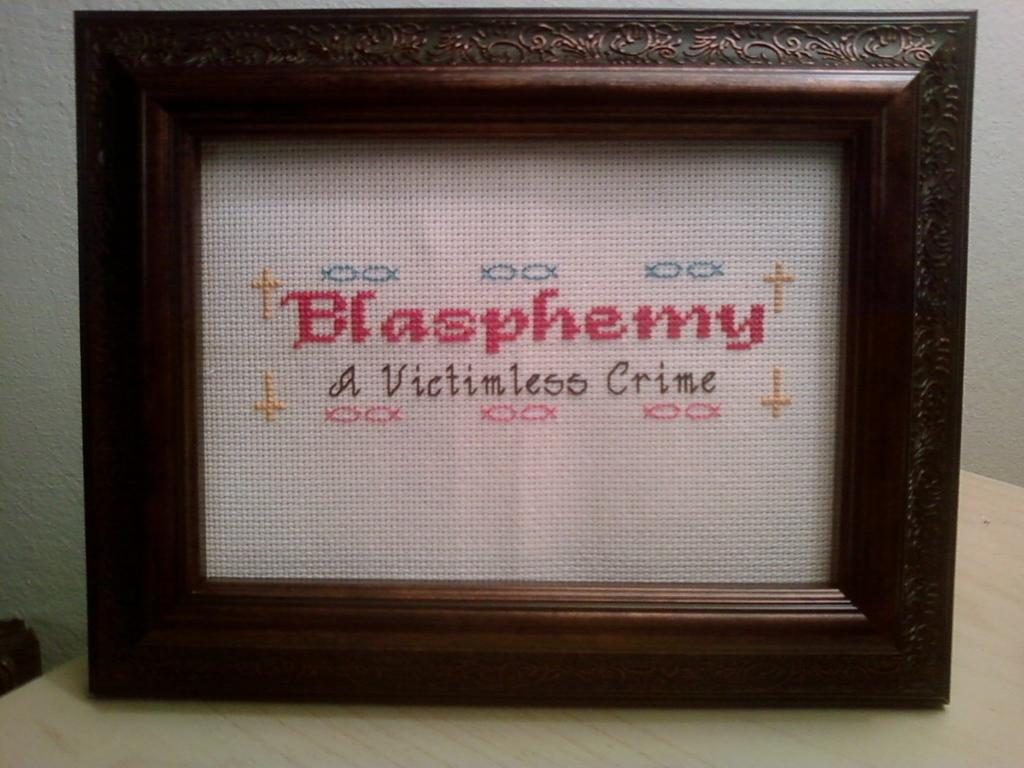<image>
Present a compact description of the photo's key features. A framed piece of needlework that reads Blasphemy  A Victimless Crime. 